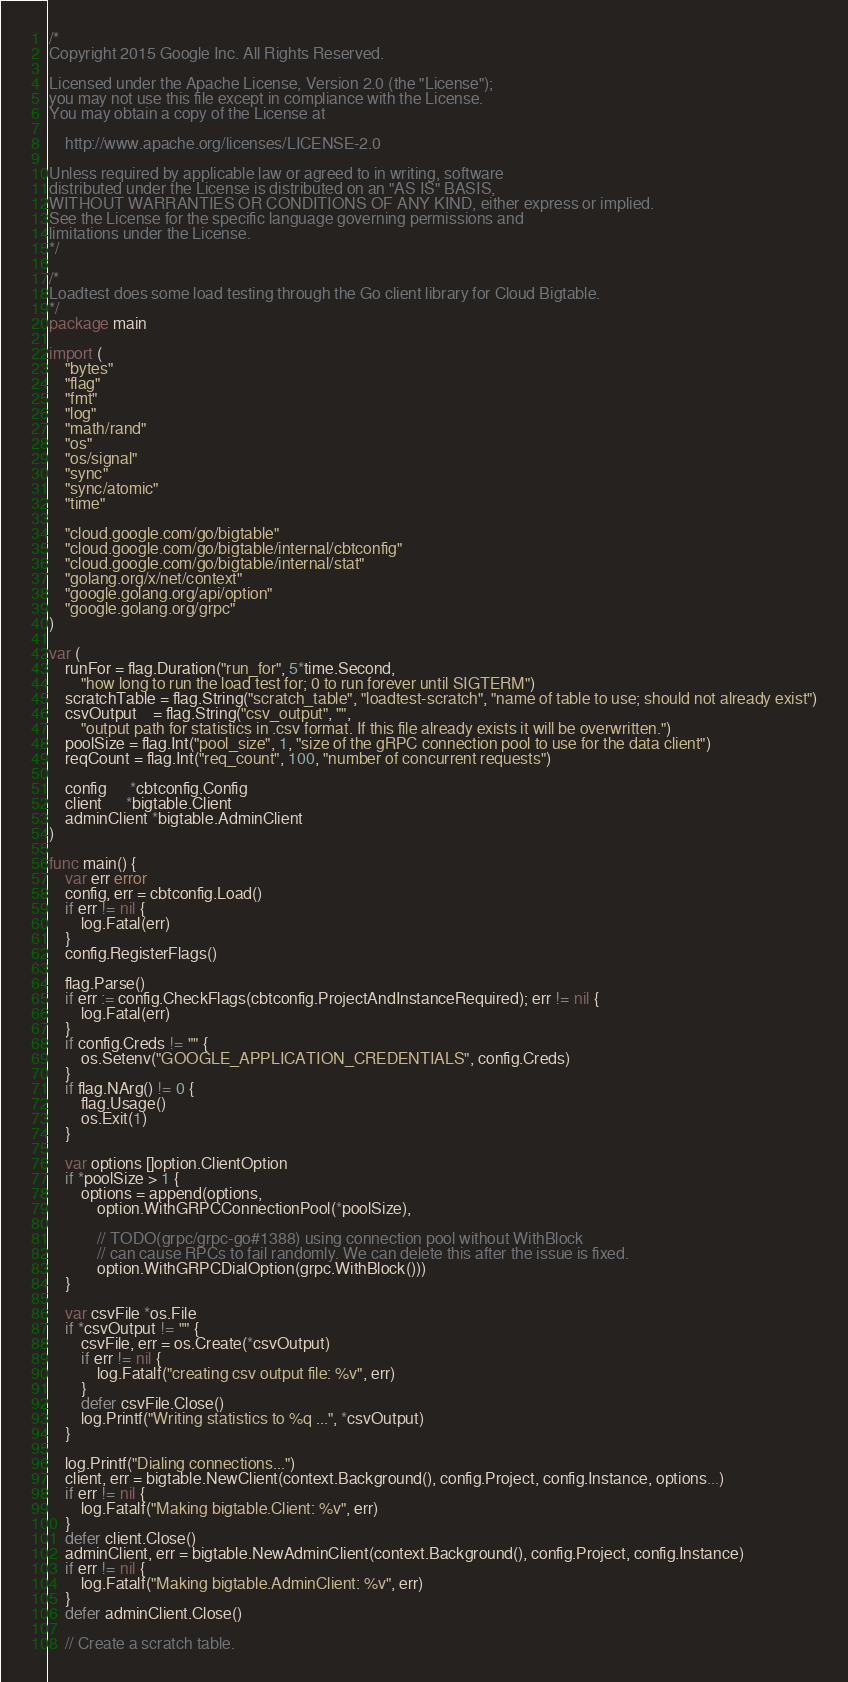Convert code to text. <code><loc_0><loc_0><loc_500><loc_500><_Go_>/*
Copyright 2015 Google Inc. All Rights Reserved.

Licensed under the Apache License, Version 2.0 (the "License");
you may not use this file except in compliance with the License.
You may obtain a copy of the License at

    http://www.apache.org/licenses/LICENSE-2.0

Unless required by applicable law or agreed to in writing, software
distributed under the License is distributed on an "AS IS" BASIS,
WITHOUT WARRANTIES OR CONDITIONS OF ANY KIND, either express or implied.
See the License for the specific language governing permissions and
limitations under the License.
*/

/*
Loadtest does some load testing through the Go client library for Cloud Bigtable.
*/
package main

import (
	"bytes"
	"flag"
	"fmt"
	"log"
	"math/rand"
	"os"
	"os/signal"
	"sync"
	"sync/atomic"
	"time"

	"cloud.google.com/go/bigtable"
	"cloud.google.com/go/bigtable/internal/cbtconfig"
	"cloud.google.com/go/bigtable/internal/stat"
	"golang.org/x/net/context"
	"google.golang.org/api/option"
	"google.golang.org/grpc"
)

var (
	runFor = flag.Duration("run_for", 5*time.Second,
		"how long to run the load test for; 0 to run forever until SIGTERM")
	scratchTable = flag.String("scratch_table", "loadtest-scratch", "name of table to use; should not already exist")
	csvOutput    = flag.String("csv_output", "",
		"output path for statistics in .csv format. If this file already exists it will be overwritten.")
	poolSize = flag.Int("pool_size", 1, "size of the gRPC connection pool to use for the data client")
	reqCount = flag.Int("req_count", 100, "number of concurrent requests")

	config      *cbtconfig.Config
	client      *bigtable.Client
	adminClient *bigtable.AdminClient
)

func main() {
	var err error
	config, err = cbtconfig.Load()
	if err != nil {
		log.Fatal(err)
	}
	config.RegisterFlags()

	flag.Parse()
	if err := config.CheckFlags(cbtconfig.ProjectAndInstanceRequired); err != nil {
		log.Fatal(err)
	}
	if config.Creds != "" {
		os.Setenv("GOOGLE_APPLICATION_CREDENTIALS", config.Creds)
	}
	if flag.NArg() != 0 {
		flag.Usage()
		os.Exit(1)
	}

	var options []option.ClientOption
	if *poolSize > 1 {
		options = append(options,
			option.WithGRPCConnectionPool(*poolSize),

			// TODO(grpc/grpc-go#1388) using connection pool without WithBlock
			// can cause RPCs to fail randomly. We can delete this after the issue is fixed.
			option.WithGRPCDialOption(grpc.WithBlock()))
	}

	var csvFile *os.File
	if *csvOutput != "" {
		csvFile, err = os.Create(*csvOutput)
		if err != nil {
			log.Fatalf("creating csv output file: %v", err)
		}
		defer csvFile.Close()
		log.Printf("Writing statistics to %q ...", *csvOutput)
	}

	log.Printf("Dialing connections...")
	client, err = bigtable.NewClient(context.Background(), config.Project, config.Instance, options...)
	if err != nil {
		log.Fatalf("Making bigtable.Client: %v", err)
	}
	defer client.Close()
	adminClient, err = bigtable.NewAdminClient(context.Background(), config.Project, config.Instance)
	if err != nil {
		log.Fatalf("Making bigtable.AdminClient: %v", err)
	}
	defer adminClient.Close()

	// Create a scratch table.</code> 